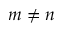Convert formula to latex. <formula><loc_0><loc_0><loc_500><loc_500>m \neq n</formula> 